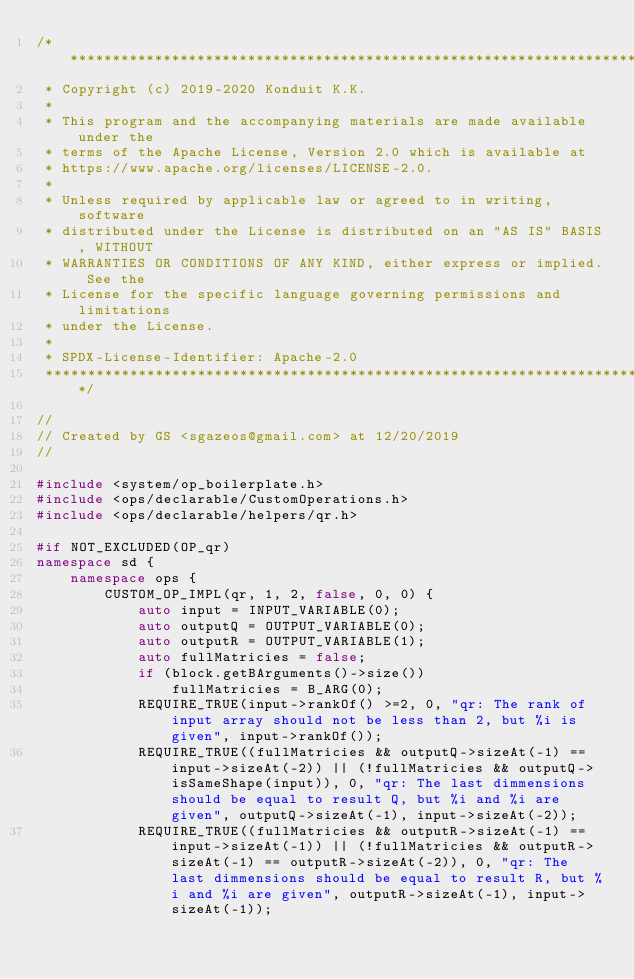<code> <loc_0><loc_0><loc_500><loc_500><_C++_>/*******************************************************************************
 * Copyright (c) 2019-2020 Konduit K.K.
 *
 * This program and the accompanying materials are made available under the
 * terms of the Apache License, Version 2.0 which is available at
 * https://www.apache.org/licenses/LICENSE-2.0.
 *
 * Unless required by applicable law or agreed to in writing, software
 * distributed under the License is distributed on an "AS IS" BASIS, WITHOUT
 * WARRANTIES OR CONDITIONS OF ANY KIND, either express or implied. See the
 * License for the specific language governing permissions and limitations
 * under the License.
 *
 * SPDX-License-Identifier: Apache-2.0
 ******************************************************************************/

//
// Created by GS <sgazeos@gmail.com> at 12/20/2019
//

#include <system/op_boilerplate.h>
#include <ops/declarable/CustomOperations.h>
#include <ops/declarable/helpers/qr.h>

#if NOT_EXCLUDED(OP_qr)
namespace sd {
    namespace ops {
        CUSTOM_OP_IMPL(qr, 1, 2, false, 0, 0) {
            auto input = INPUT_VARIABLE(0);
            auto outputQ = OUTPUT_VARIABLE(0);
            auto outputR = OUTPUT_VARIABLE(1);
            auto fullMatricies = false;
            if (block.getBArguments()->size())
                fullMatricies = B_ARG(0);
            REQUIRE_TRUE(input->rankOf() >=2, 0, "qr: The rank of input array should not be less than 2, but %i is given", input->rankOf());
            REQUIRE_TRUE((fullMatricies && outputQ->sizeAt(-1) == input->sizeAt(-2)) || (!fullMatricies && outputQ->isSameShape(input)), 0, "qr: The last dimmensions should be equal to result Q, but %i and %i are given", outputQ->sizeAt(-1), input->sizeAt(-2));
            REQUIRE_TRUE((fullMatricies && outputR->sizeAt(-1) == input->sizeAt(-1)) || (!fullMatricies && outputR->sizeAt(-1) == outputR->sizeAt(-2)), 0, "qr: The last dimmensions should be equal to result R, but %i and %i are given", outputR->sizeAt(-1), input->sizeAt(-1));</code> 